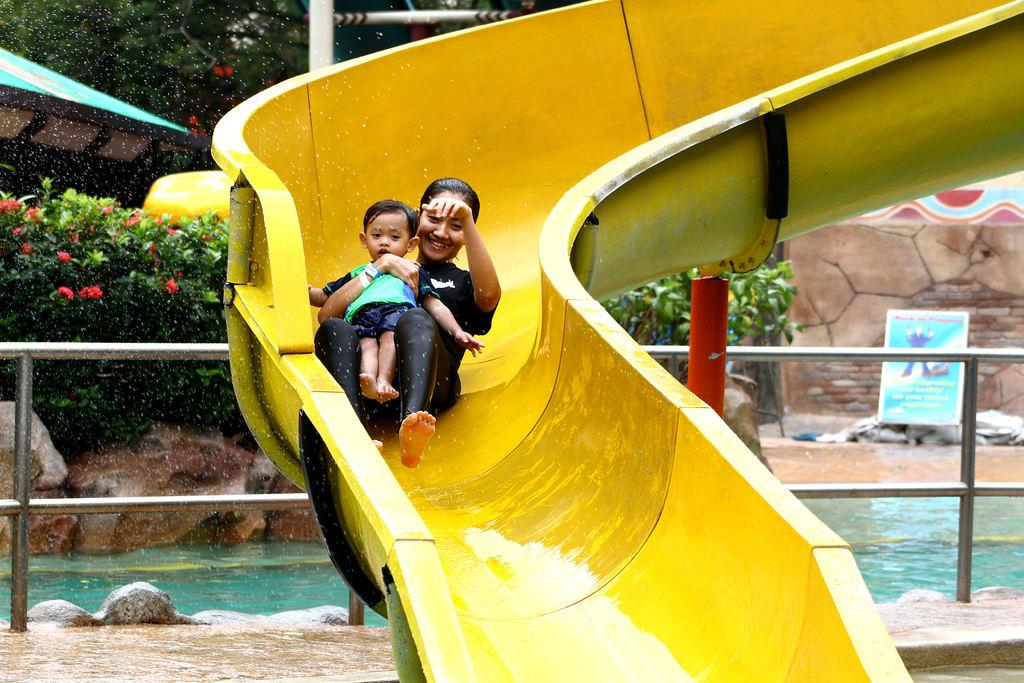Who is present in the image? There is a woman in the image. What is the woman holding? The woman is holding a baby. Where is the baby positioned in the image? The baby is on a slide. What can be seen in the background of the image? There are trees, plants with flowers, rocks, a swimming pool, a shed, an information board, and grills in the background of the image. What type of cork can be seen in the mouth of the baby in the image? There is no cork present in the image, and the baby's mouth is not visible. What kind of bone is the woman using to play with the baby in the image? There is no bone present in the image, and the woman is not using any object to play with the baby. 